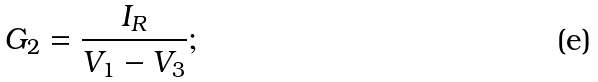Convert formula to latex. <formula><loc_0><loc_0><loc_500><loc_500>G _ { 2 } = \frac { I _ { R } } { V _ { 1 } - V _ { 3 } } ;</formula> 